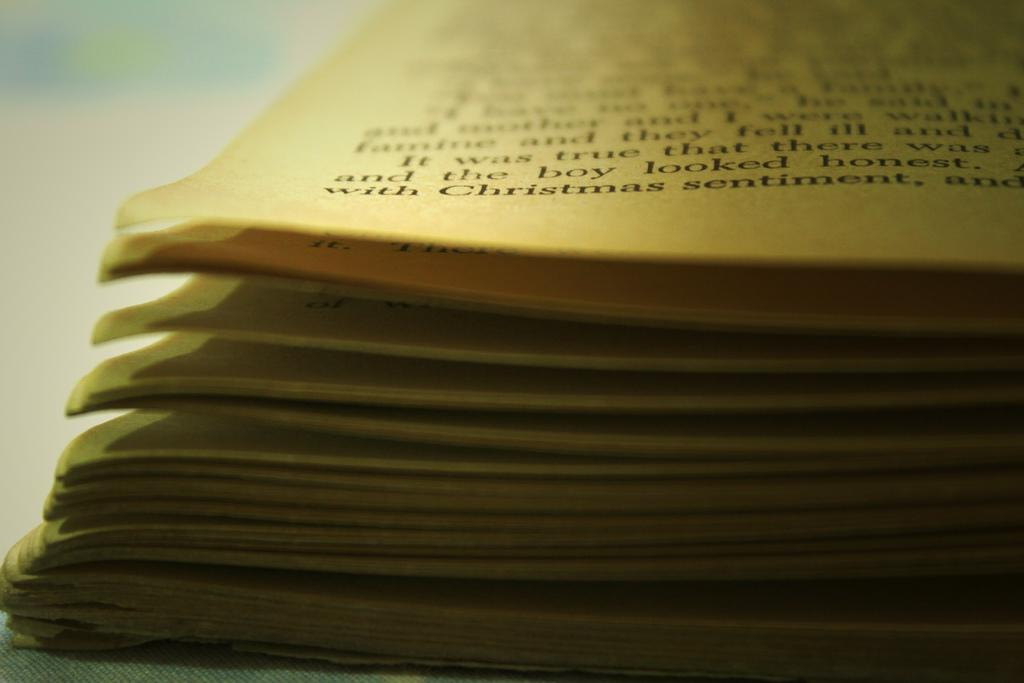<image>
Create a compact narrative representing the image presented. A book is open and the word Christmas can be seen in the bottom left corner. 